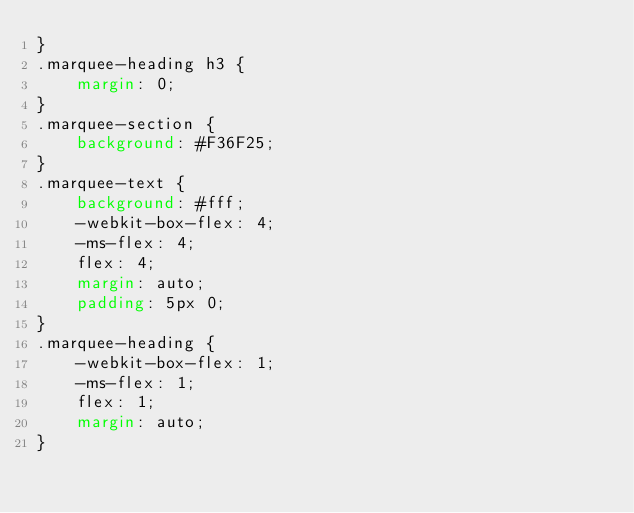<code> <loc_0><loc_0><loc_500><loc_500><_CSS_>}
.marquee-heading h3 {
    margin: 0;
}
.marquee-section {
    background: #F36F25;
}
.marquee-text {
    background: #fff;
    -webkit-box-flex: 4;
    -ms-flex: 4;
    flex: 4;
    margin: auto;
    padding: 5px 0;
}
.marquee-heading {
    -webkit-box-flex: 1;
    -ms-flex: 1;
    flex: 1;
    margin: auto;
}</code> 